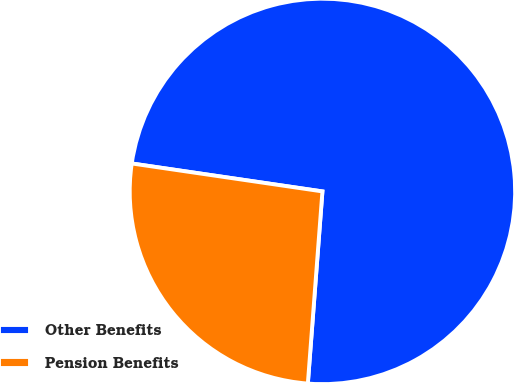Convert chart to OTSL. <chart><loc_0><loc_0><loc_500><loc_500><pie_chart><fcel>Other Benefits<fcel>Pension Benefits<nl><fcel>73.89%<fcel>26.11%<nl></chart> 